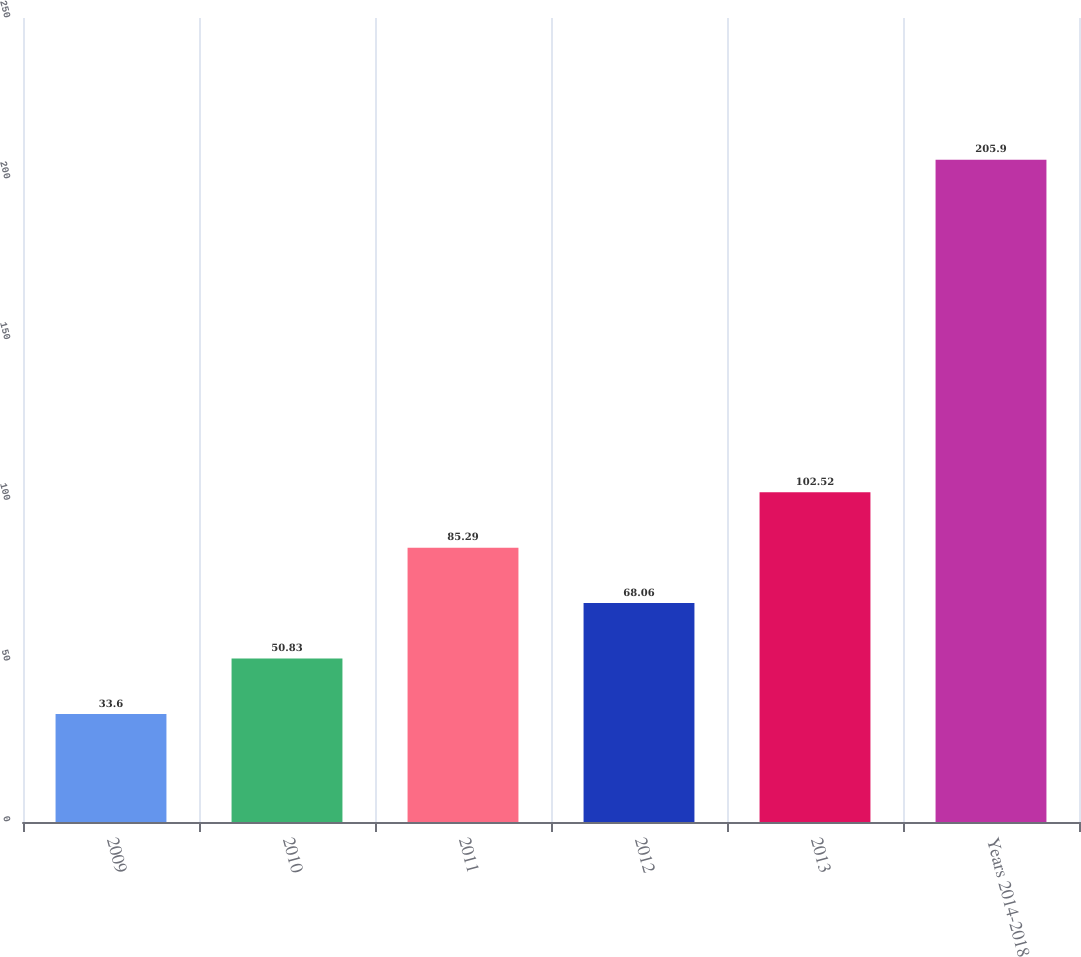<chart> <loc_0><loc_0><loc_500><loc_500><bar_chart><fcel>2009<fcel>2010<fcel>2011<fcel>2012<fcel>2013<fcel>Years 2014-2018<nl><fcel>33.6<fcel>50.83<fcel>85.29<fcel>68.06<fcel>102.52<fcel>205.9<nl></chart> 